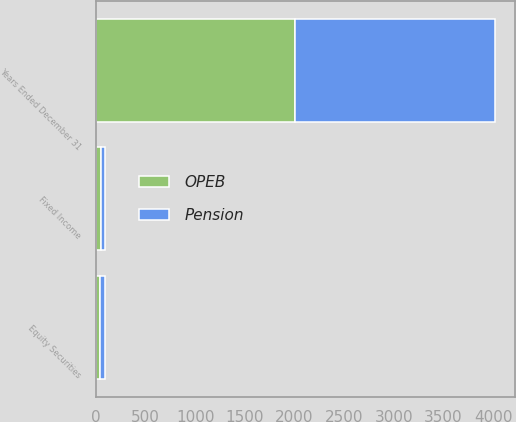<chart> <loc_0><loc_0><loc_500><loc_500><stacked_bar_chart><ecel><fcel>Years Ended December 31<fcel>Fixed Income<fcel>Equity Securities<nl><fcel>Pension<fcel>2008<fcel>37<fcel>50<nl><fcel>OPEB<fcel>2008<fcel>55<fcel>45<nl></chart> 